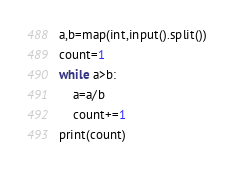Convert code to text. <code><loc_0><loc_0><loc_500><loc_500><_Python_>a,b=map(int,input().split())
count=1
while a>b:
    a=a/b
    count+=1
print(count)</code> 